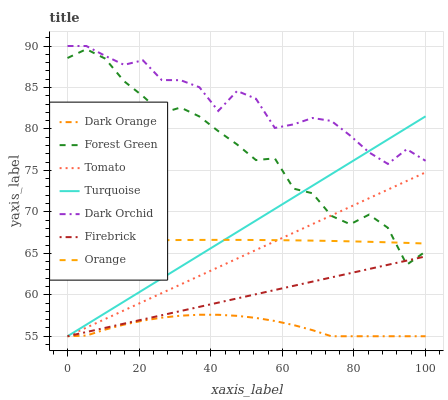Does Dark Orange have the minimum area under the curve?
Answer yes or no. Yes. Does Dark Orchid have the maximum area under the curve?
Answer yes or no. Yes. Does Turquoise have the minimum area under the curve?
Answer yes or no. No. Does Turquoise have the maximum area under the curve?
Answer yes or no. No. Is Firebrick the smoothest?
Answer yes or no. Yes. Is Forest Green the roughest?
Answer yes or no. Yes. Is Dark Orange the smoothest?
Answer yes or no. No. Is Dark Orange the roughest?
Answer yes or no. No. Does Dark Orchid have the lowest value?
Answer yes or no. No. Does Turquoise have the highest value?
Answer yes or no. No. Is Dark Orange less than Dark Orchid?
Answer yes or no. Yes. Is Dark Orchid greater than Orange?
Answer yes or no. Yes. Does Dark Orange intersect Dark Orchid?
Answer yes or no. No. 